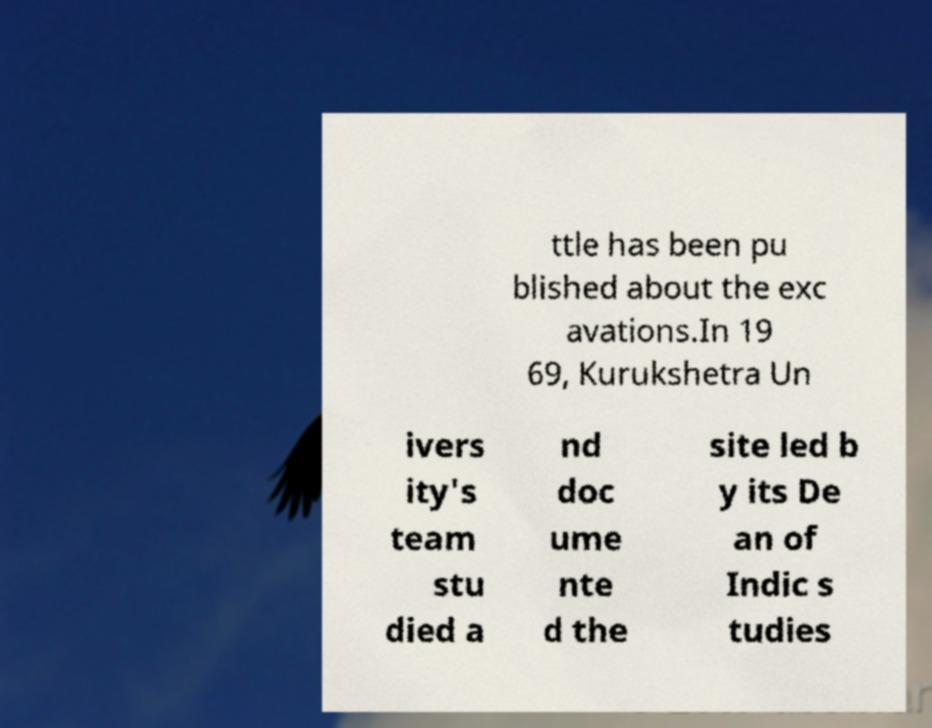Could you extract and type out the text from this image? ttle has been pu blished about the exc avations.In 19 69, Kurukshetra Un ivers ity's team stu died a nd doc ume nte d the site led b y its De an of Indic s tudies 